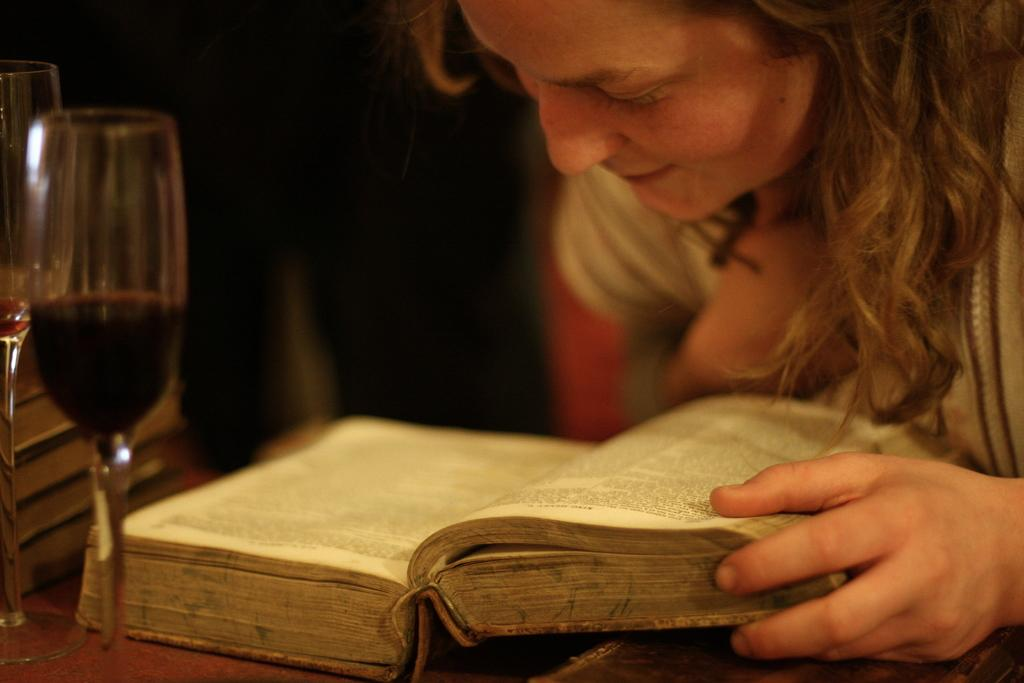Who is the main subject in the image? There is a lady in the image. What is the lady holding in the image? The lady is holding a book. Where is the book located in the image? The book is on a table. What else can be seen in the image besides the lady and the book? There are glasses in the image. How many friends are sitting with the lady in the image? There are no friends present in the image; it only features the lady holding a book. What type of knowledge can be gained from the kettle in the image? There is no kettle present in the image, so no knowledge can be gained from it. 